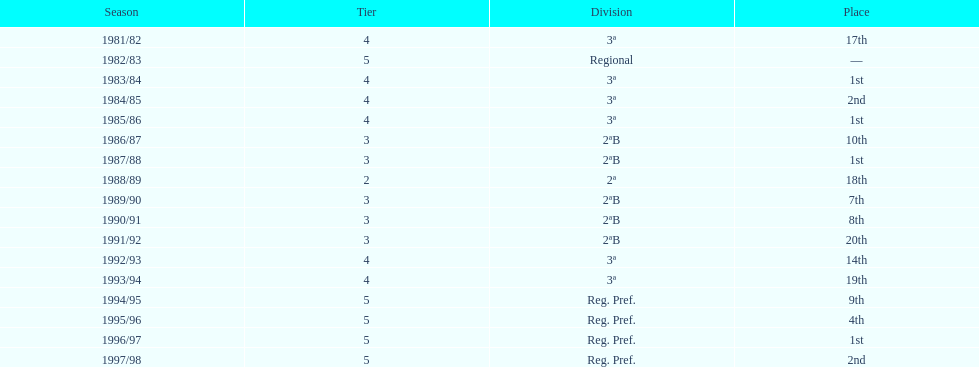In which rank was ud alzira a member the least? 2. 